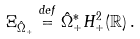<formula> <loc_0><loc_0><loc_500><loc_500>\Xi _ { \hat { \Omega } _ { + } } \stackrel { d e f } { = } \hat { \Omega } _ { + } ^ { * } H ^ { 2 } _ { + } ( \mathbb { R } ) \, .</formula> 